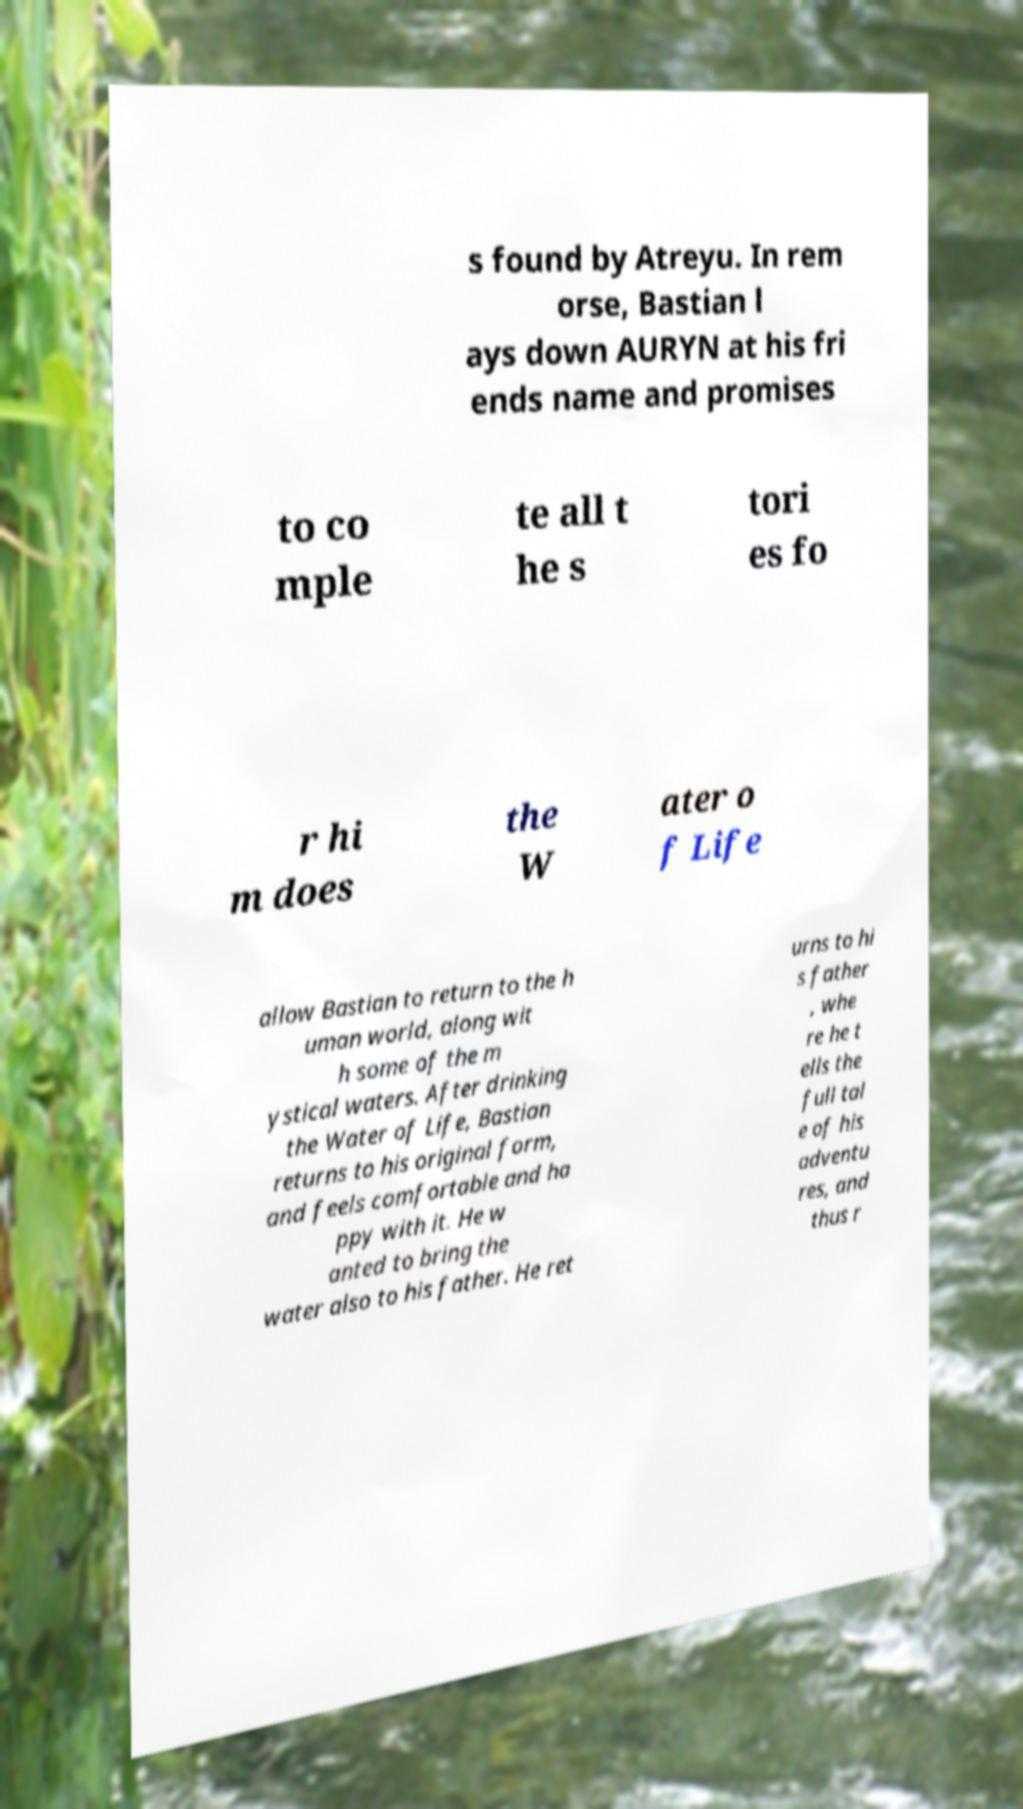There's text embedded in this image that I need extracted. Can you transcribe it verbatim? s found by Atreyu. In rem orse, Bastian l ays down AURYN at his fri ends name and promises to co mple te all t he s tori es fo r hi m does the W ater o f Life allow Bastian to return to the h uman world, along wit h some of the m ystical waters. After drinking the Water of Life, Bastian returns to his original form, and feels comfortable and ha ppy with it. He w anted to bring the water also to his father. He ret urns to hi s father , whe re he t ells the full tal e of his adventu res, and thus r 